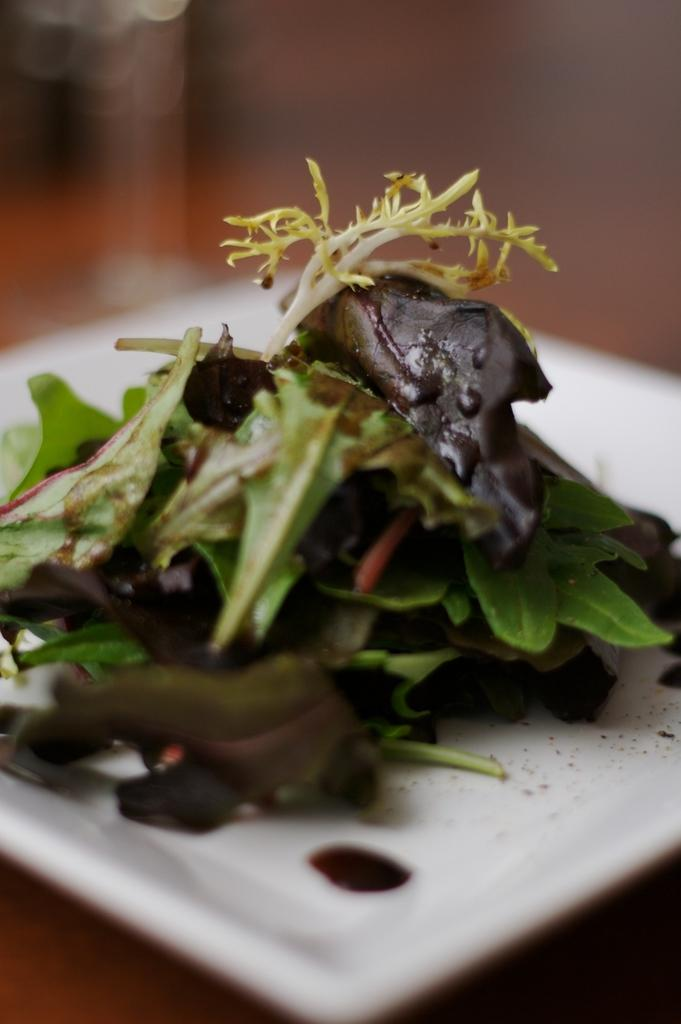What piece of furniture is present in the image? There is a table in the image. What is placed on the table? There is a plate on the table. What is on the plate? There is a food item in the plate. Can you describe the background of the image? The background of the image is blurred. What type of planes can be seen flying in the image? There are no planes visible in the image; it only features a table, a plate, and a food item. How does the behavior of the food item change throughout the image? The food item does not change its behavior in the image, as it is stationary on the plate. 